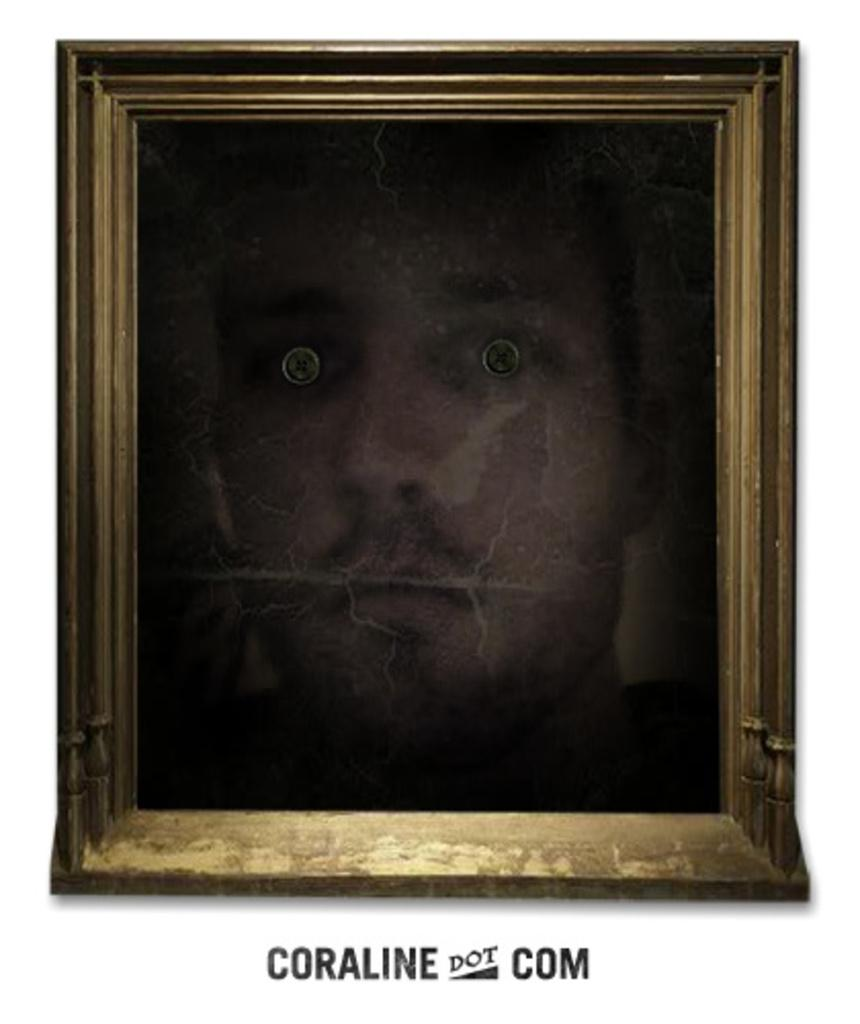<image>
Summarize the visual content of the image. A framed picture with the writing Carolina Dot Com below it. 